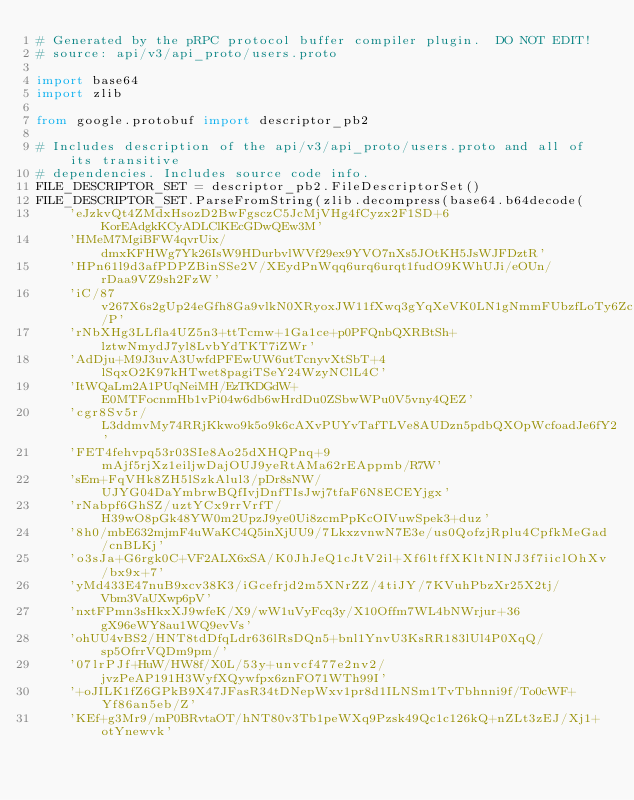Convert code to text. <code><loc_0><loc_0><loc_500><loc_500><_Python_># Generated by the pRPC protocol buffer compiler plugin.  DO NOT EDIT!
# source: api/v3/api_proto/users.proto

import base64
import zlib

from google.protobuf import descriptor_pb2

# Includes description of the api/v3/api_proto/users.proto and all of its transitive
# dependencies. Includes source code info.
FILE_DESCRIPTOR_SET = descriptor_pb2.FileDescriptorSet()
FILE_DESCRIPTOR_SET.ParseFromString(zlib.decompress(base64.b64decode(
    'eJzkvQt4ZMdxHsozD2BwFgsczC5JcMjVHg4fCyzx2F1SD+6KorEAdgkKCyADLClKEcGDwQEw3M'
    'HMeM7MgiBFW4qvrUix/dmxKFHWg7Yk26IsW9HDurbvlWVf29ex9YVO7nXs5JOtKH5JsWJFDztR'
    'HPn61l9d3afPDPZBinSSe2V/XEydPnWqq6urq6urqt1fudO9KWhUJi/eOUn/rDaa9VZ9sh2FzW'
    'iC/87v267X6s2gUp24eGfh8Ga9vlkN0XRyoxJW11fXwq3gYqXeVK0LN1gNmmFUbzfLoTy6Zc/P'
    'rNbXHg3LLfla4UZ5n3+ttTcmw+1Ga1ce+p0PFQnbQXRBtSh+lztwNmydJ7yl8LvbYdTKT7iZWr'
    'AdDju+M9J3uvA3UwfdPFEwUW6utTcnyvXtSbT+4lSqxO2K97kHTwet8pagiTSeY24WzyNClL4C'
    'ItWQaLm2A1PUqNeiMH/EzTKDGdW+E0MTFocnmHb1vPi04w6db6wHrdDu0ZSbwWPu0V5vny4QEZ'
    'cgr8Sv5r/L3ddmvMy74RRjKkwo9k5o9k6cAXvPUYvTafTLVe8AUDzn5pdbQXOpWcfoadJe6fY2'
    'FET4fehvpq53r03SIe8Ao25dXHQPnq+9mAjf5rjXz1eiljwDajOUJ9yeRtAMa62rEAppmb/R7W'
    'sEm+FqVHk8ZH5lSzkAlul3/pDr8sNW/UJYG04DaYmbrwBQfIvjDnfTIsJwj7tfaF6N8ECEYjgx'
    'rNabpf6GhSZ/uztYCx9rrVrfT/H39wO8pGk48YW0m2UpzJ9ye0Ui8zcmPpKcOIVuwSpek3+duz'
    '8h0/mbE632mjmF4uWaKC4Q5inXjUU9/7LkxzvnwN7E3e/us0QofzjRplu4CpfkMeGad/cnBLKj'
    'o3sJa+G6rgk0C+VF2ALX6xSA/K0JhJeQ1cJtV2il+Xf6ltffXKltNINJ3f7iiclOhXv/bx9x+7'
    'yMd433E47nuB9xcv38K3/iGcefrjd2m5XNrZZ/4tiJY/7KVuhPbzXr25X2tj/Vbm3VaUXwp6pV'
    'nxtFPmn3sHkxXJ9wfeK/X9/wW1uVyFcq3y/X10Offm7WL4bNWrjur+36gX96eWY8au1WQ9evVs'
    'ohUU4vBS2/HNT8tdDfqLdr636lRsDQn5+bnl1YnvU3KsRR183lUl4P0XqQ/sp5OfrrVQDm9pm/'
    '07lrPJf+HuW/HW8f/X0L/53y+unvcf477e2nv2/jvzPeAP191H3WyfXQywfpx6znFO71WTh99I'
    '+oJILK1fZ6GPkB9X47JFasR34tDNepWxv1pr8d1ILNSm1TvTbhnni9f/To0cWF+Yf86an5eb/Z'
    'KEf+g3Mr9/mP0BRvtaOT/hNT80v3Tb1peWXq9Pzsk49Qc1c126kQ+nZLt3zEJ/Xj1+otYnewvk'</code> 